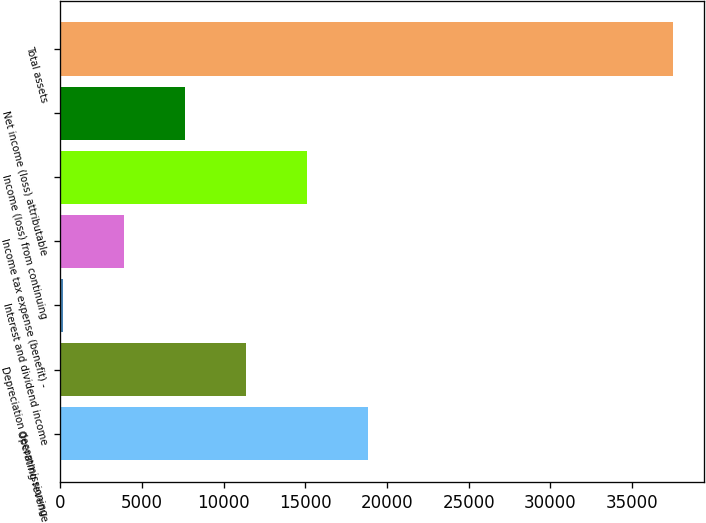Convert chart to OTSL. <chart><loc_0><loc_0><loc_500><loc_500><bar_chart><fcel>Operating revenue<fcel>Depreciation decommissioning<fcel>Interest and dividend income<fcel>Income tax expense (benefit) -<fcel>Income (loss) from continuing<fcel>Net income (loss) attributable<fcel>Total assets<nl><fcel>18838.5<fcel>11364.7<fcel>154<fcel>3890.9<fcel>15101.6<fcel>7627.8<fcel>37523<nl></chart> 